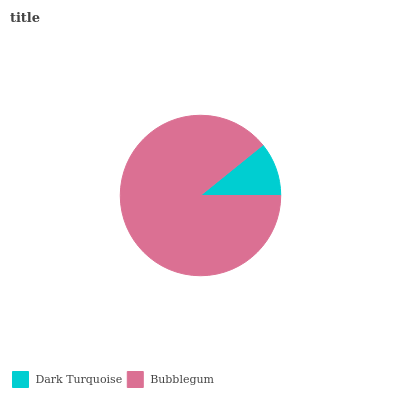Is Dark Turquoise the minimum?
Answer yes or no. Yes. Is Bubblegum the maximum?
Answer yes or no. Yes. Is Bubblegum the minimum?
Answer yes or no. No. Is Bubblegum greater than Dark Turquoise?
Answer yes or no. Yes. Is Dark Turquoise less than Bubblegum?
Answer yes or no. Yes. Is Dark Turquoise greater than Bubblegum?
Answer yes or no. No. Is Bubblegum less than Dark Turquoise?
Answer yes or no. No. Is Bubblegum the high median?
Answer yes or no. Yes. Is Dark Turquoise the low median?
Answer yes or no. Yes. Is Dark Turquoise the high median?
Answer yes or no. No. Is Bubblegum the low median?
Answer yes or no. No. 